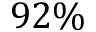Convert formula to latex. <formula><loc_0><loc_0><loc_500><loc_500>9 2 \%</formula> 